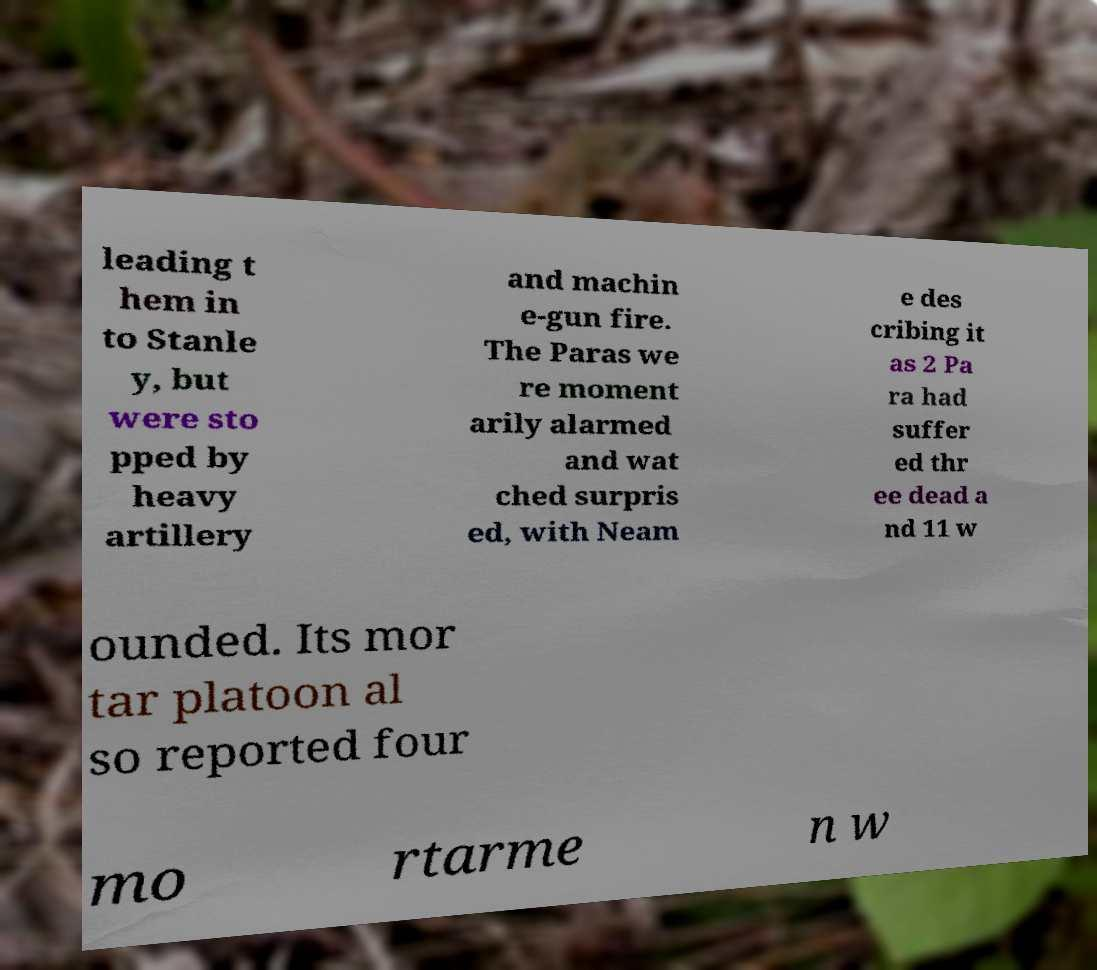What messages or text are displayed in this image? I need them in a readable, typed format. leading t hem in to Stanle y, but were sto pped by heavy artillery and machin e-gun fire. The Paras we re moment arily alarmed and wat ched surpris ed, with Neam e des cribing it as 2 Pa ra had suffer ed thr ee dead a nd 11 w ounded. Its mor tar platoon al so reported four mo rtarme n w 